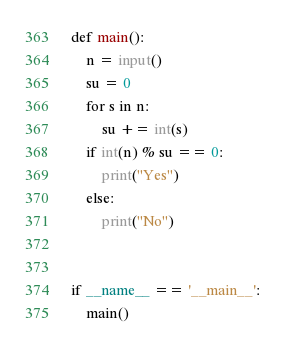<code> <loc_0><loc_0><loc_500><loc_500><_Python_>def main():
    n = input()
    su = 0
    for s in n:
        su += int(s)
    if int(n) % su == 0:
        print("Yes")
    else:
        print("No")


if __name__ == '__main__':
    main()
</code> 